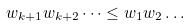Convert formula to latex. <formula><loc_0><loc_0><loc_500><loc_500>w _ { k + 1 } w _ { k + 2 } \dots \leq w _ { 1 } w _ { 2 } \dots</formula> 